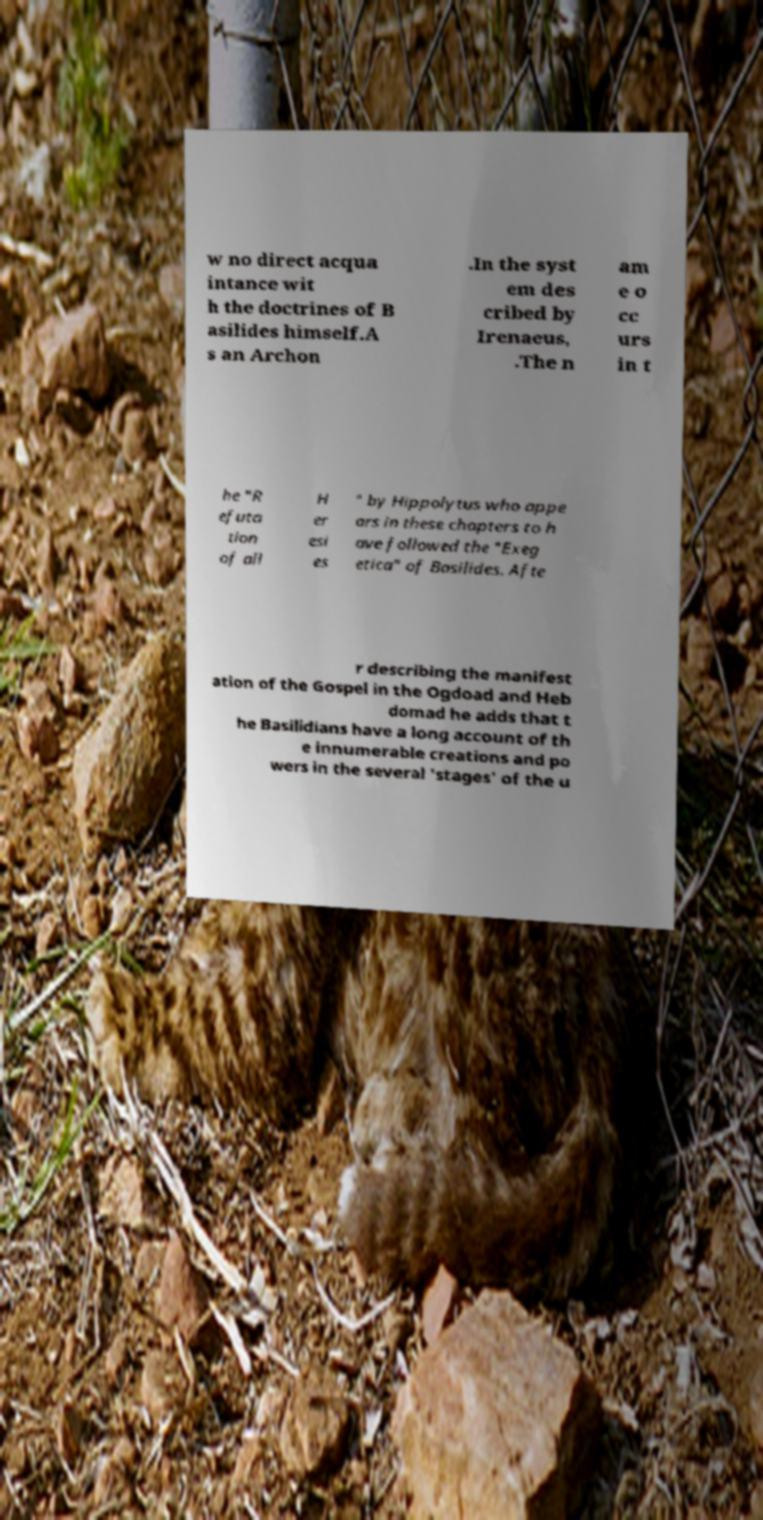Could you assist in decoding the text presented in this image and type it out clearly? w no direct acqua intance wit h the doctrines of B asilides himself.A s an Archon .In the syst em des cribed by Irenaeus, .The n am e o cc urs in t he "R efuta tion of all H er esi es " by Hippolytus who appe ars in these chapters to h ave followed the "Exeg etica" of Basilides. Afte r describing the manifest ation of the Gospel in the Ogdoad and Heb domad he adds that t he Basilidians have a long account of th e innumerable creations and po wers in the several 'stages' of the u 